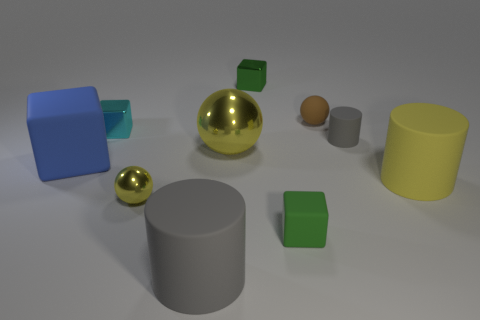Are the yellow cylinder that is to the right of the tiny brown rubber object and the green block behind the tiny metallic ball made of the same material?
Ensure brevity in your answer.  No. How many large things are either gray shiny spheres or cyan cubes?
Your response must be concise. 0. The small yellow thing that is made of the same material as the large yellow ball is what shape?
Offer a very short reply. Sphere. Is the number of tiny brown rubber spheres behind the tiny yellow metal sphere less than the number of tiny green rubber cubes?
Offer a very short reply. No. Does the small brown rubber thing have the same shape as the large yellow rubber object?
Provide a short and direct response. No. What number of matte things are either large gray cylinders or gray objects?
Offer a terse response. 2. Is there a green metallic block that has the same size as the matte sphere?
Make the answer very short. Yes. There is a metallic thing that is the same color as the tiny shiny ball; what is its shape?
Your response must be concise. Sphere. What number of yellow objects are the same size as the brown matte ball?
Provide a short and direct response. 1. There is a rubber cube in front of the blue thing; does it have the same size as the rubber sphere that is behind the big blue block?
Make the answer very short. Yes. 